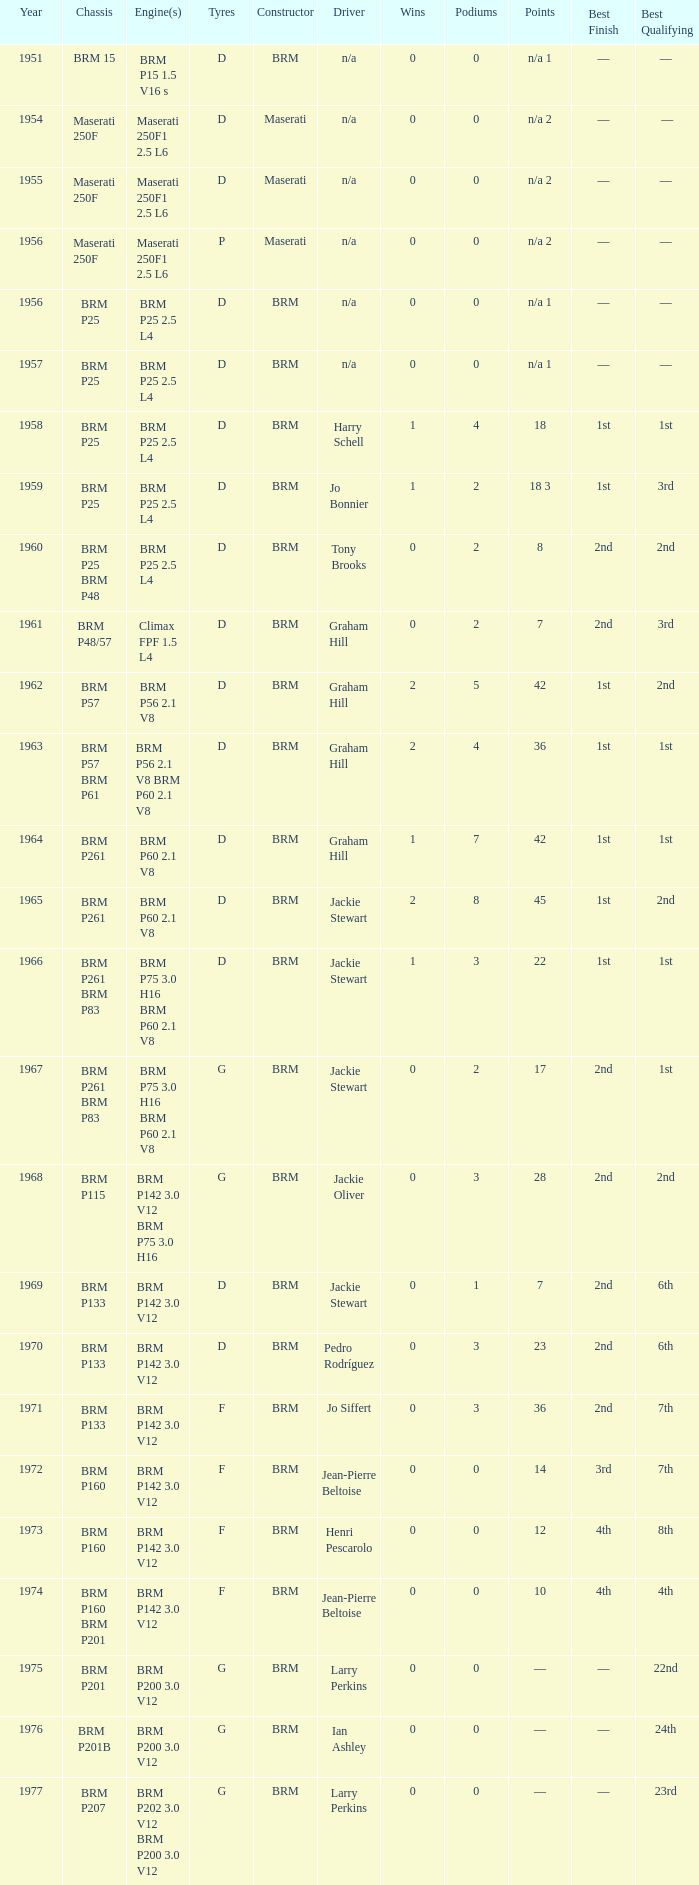Help me parse the entirety of this table. {'header': ['Year', 'Chassis', 'Engine(s)', 'Tyres', 'Constructor', 'Driver', 'Wins', 'Podiums', 'Points', 'Best Finish', 'Best Qualifying '], 'rows': [['1951', 'BRM 15', 'BRM P15 1.5 V16 s', 'D', 'BRM', 'n/a', '0', '0', 'n/a 1', '—', '— '], ['1954', 'Maserati 250F', 'Maserati 250F1 2.5 L6', 'D', 'Maserati', 'n/a', '0', '0', 'n/a 2', '—', '—'], ['1955', 'Maserati 250F', 'Maserati 250F1 2.5 L6', 'D', 'Maserati', 'n/a', '0', '0', 'n/a 2', '—', '— '], ['1956', 'Maserati 250F', 'Maserati 250F1 2.5 L6', 'P', 'Maserati', 'n/a', '0', '0', 'n/a 2', '—', '— '], ['1956', 'BRM P25', 'BRM P25 2.5 L4', 'D', 'BRM', 'n/a', '0', '0', 'n/a 1', '—', '— '], ['1957', 'BRM P25', 'BRM P25 2.5 L4', 'D', 'BRM', 'n/a', '0', '0', 'n/a 1', '—', '— '], ['1958', 'BRM P25', 'BRM P25 2.5 L4', 'D', 'BRM', 'Harry Schell', '1', '4', '18', '1st', '1st '], ['1959', 'BRM P25', 'BRM P25 2.5 L4', 'D', 'BRM', 'Jo Bonnier', '1', '2', '18 3', '1st', '3rd '], ['1960', 'BRM P25 BRM P48', 'BRM P25 2.5 L4', 'D', 'BRM', 'Tony Brooks', '0', '2', '8', '2nd', '2nd '], ['1961', 'BRM P48/57', 'Climax FPF 1.5 L4', 'D', 'BRM', 'Graham Hill', '0', '2', '7', '2nd', '3rd '], ['1962', 'BRM P57', 'BRM P56 2.1 V8', 'D', 'BRM', 'Graham Hill', '2', '5', '42', '1st', '2nd '], ['1963', 'BRM P57 BRM P61', 'BRM P56 2.1 V8 BRM P60 2.1 V8', 'D', 'BRM', 'Graham Hill', '2', '4', '36', '1st', '1st '], ['1964', 'BRM P261', 'BRM P60 2.1 V8', 'D', 'BRM', 'Graham Hill', '1', '7', '42', '1st', '1st '], ['1965', 'BRM P261', 'BRM P60 2.1 V8', 'D', 'BRM', 'Jackie Stewart', '2', '8', '45', '1st', '2nd '], ['1966', 'BRM P261 BRM P83', 'BRM P75 3.0 H16 BRM P60 2.1 V8', 'D', 'BRM', 'Jackie Stewart', '1', '3', '22', '1st', '1st '], ['1967', 'BRM P261 BRM P83', 'BRM P75 3.0 H16 BRM P60 2.1 V8', 'G', 'BRM', 'Jackie Stewart', '0', '2', '17', '2nd', '1st '], ['1968', 'BRM P115', 'BRM P142 3.0 V12 BRM P75 3.0 H16', 'G', 'BRM', 'Jackie Oliver', '0', '3', '28', '2nd', '2nd '], ['1969', 'BRM P133', 'BRM P142 3.0 V12', 'D', 'BRM', 'Jackie Stewart', '0', '1', '7', '2nd', '6th '], ['1970', 'BRM P133', 'BRM P142 3.0 V12', 'D', 'BRM', 'Pedro Rodríguez', '0', '3', '23', '2nd', '6th '], ['1971', 'BRM P133', 'BRM P142 3.0 V12', 'F', 'BRM', 'Jo Siffert', '0', '3', '36', '2nd', '7th '], ['1972', 'BRM P160', 'BRM P142 3.0 V12', 'F', 'BRM', 'Jean-Pierre Beltoise', '0', '0', '14', '3rd', '7th '], ['1973', 'BRM P160', 'BRM P142 3.0 V12', 'F', 'BRM', 'Henri Pescarolo', '0', '0', '12', '4th', '8th '], ['1974', 'BRM P160 BRM P201', 'BRM P142 3.0 V12', 'F', 'BRM', 'Jean-Pierre Beltoise', '0', '0', '10', '4th', '4th '], ['1975', 'BRM P201', 'BRM P200 3.0 V12', 'G', 'BRM', 'Larry Perkins', '0', '0', '—', '—', '22nd '], ['1976', 'BRM P201B', 'BRM P200 3.0 V12', 'G', 'BRM', 'Ian Ashley', '0', '0', '—', '—', '24th '], ['1977', 'BRM P207', 'BRM P202 3.0 V12 BRM P200 3.0 V12', 'G', 'BRM', 'Larry Perkins', '0', '0', '—', '—', '23rd ']]} Name the chassis of 1961 BRM P48/57. 